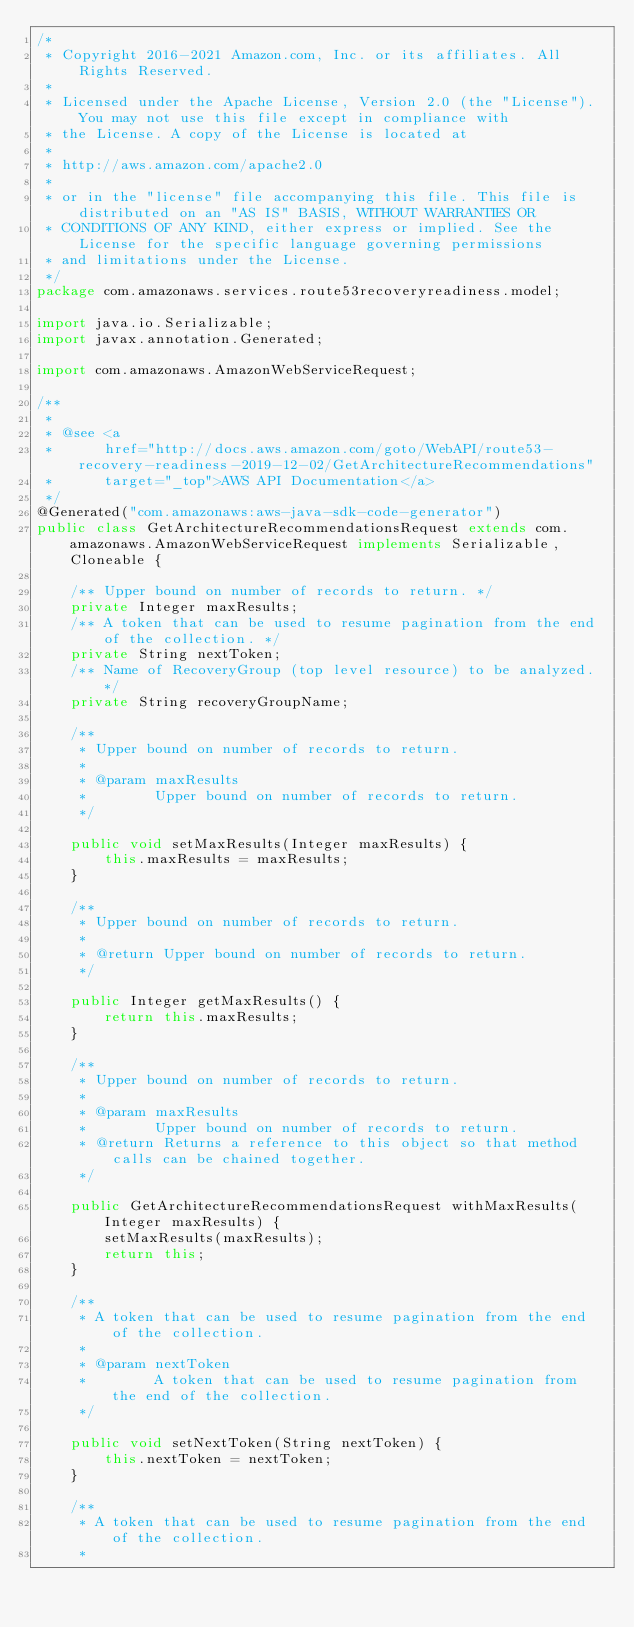Convert code to text. <code><loc_0><loc_0><loc_500><loc_500><_Java_>/*
 * Copyright 2016-2021 Amazon.com, Inc. or its affiliates. All Rights Reserved.
 * 
 * Licensed under the Apache License, Version 2.0 (the "License"). You may not use this file except in compliance with
 * the License. A copy of the License is located at
 * 
 * http://aws.amazon.com/apache2.0
 * 
 * or in the "license" file accompanying this file. This file is distributed on an "AS IS" BASIS, WITHOUT WARRANTIES OR
 * CONDITIONS OF ANY KIND, either express or implied. See the License for the specific language governing permissions
 * and limitations under the License.
 */
package com.amazonaws.services.route53recoveryreadiness.model;

import java.io.Serializable;
import javax.annotation.Generated;

import com.amazonaws.AmazonWebServiceRequest;

/**
 * 
 * @see <a
 *      href="http://docs.aws.amazon.com/goto/WebAPI/route53-recovery-readiness-2019-12-02/GetArchitectureRecommendations"
 *      target="_top">AWS API Documentation</a>
 */
@Generated("com.amazonaws:aws-java-sdk-code-generator")
public class GetArchitectureRecommendationsRequest extends com.amazonaws.AmazonWebServiceRequest implements Serializable, Cloneable {

    /** Upper bound on number of records to return. */
    private Integer maxResults;
    /** A token that can be used to resume pagination from the end of the collection. */
    private String nextToken;
    /** Name of RecoveryGroup (top level resource) to be analyzed. */
    private String recoveryGroupName;

    /**
     * Upper bound on number of records to return.
     * 
     * @param maxResults
     *        Upper bound on number of records to return.
     */

    public void setMaxResults(Integer maxResults) {
        this.maxResults = maxResults;
    }

    /**
     * Upper bound on number of records to return.
     * 
     * @return Upper bound on number of records to return.
     */

    public Integer getMaxResults() {
        return this.maxResults;
    }

    /**
     * Upper bound on number of records to return.
     * 
     * @param maxResults
     *        Upper bound on number of records to return.
     * @return Returns a reference to this object so that method calls can be chained together.
     */

    public GetArchitectureRecommendationsRequest withMaxResults(Integer maxResults) {
        setMaxResults(maxResults);
        return this;
    }

    /**
     * A token that can be used to resume pagination from the end of the collection.
     * 
     * @param nextToken
     *        A token that can be used to resume pagination from the end of the collection.
     */

    public void setNextToken(String nextToken) {
        this.nextToken = nextToken;
    }

    /**
     * A token that can be used to resume pagination from the end of the collection.
     * </code> 